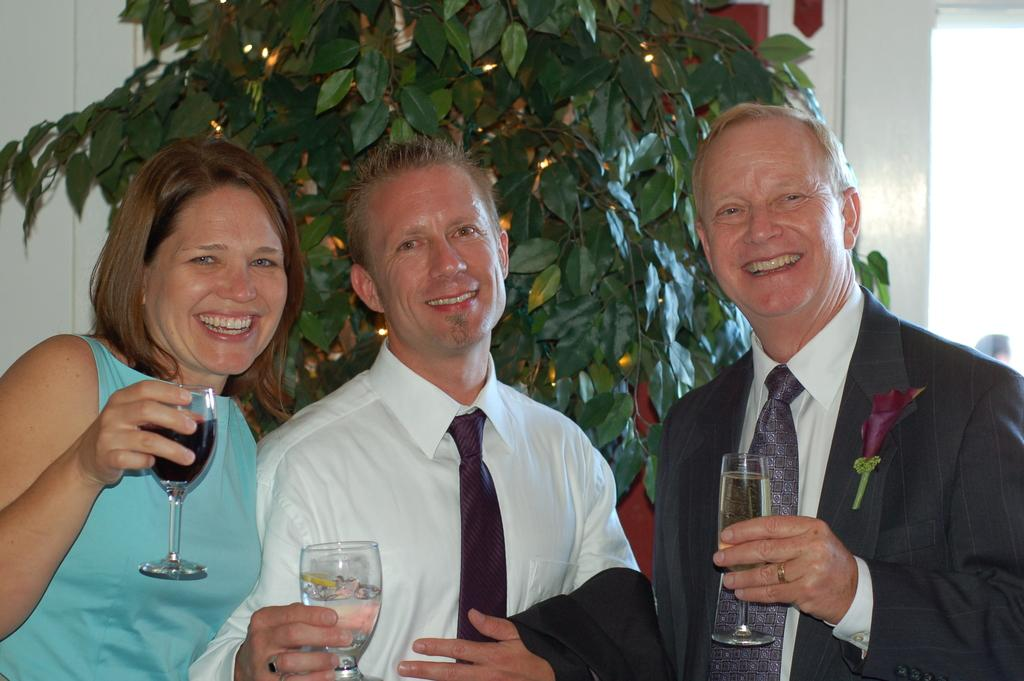What can be seen in the background of the image? There is a plant in the background of the image. How many people are in the image? There are three persons standing in the image. What are the persons holding in their hands? The persons are holding drinking glasses in their hands. What is the facial expression of the persons in the image? The persons are smiling in the image. What are the persons doing in the image? They are posing for the camera. What day of the week is it in the image? The day of the week is not mentioned or visible in the image. Is there a daughter present in the image? There is no mention of a daughter or any specific family relationship in the image. 